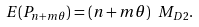<formula> <loc_0><loc_0><loc_500><loc_500>E ( P _ { n + m \theta } ) = ( n + m \theta ) \ M _ { D 2 } .</formula> 